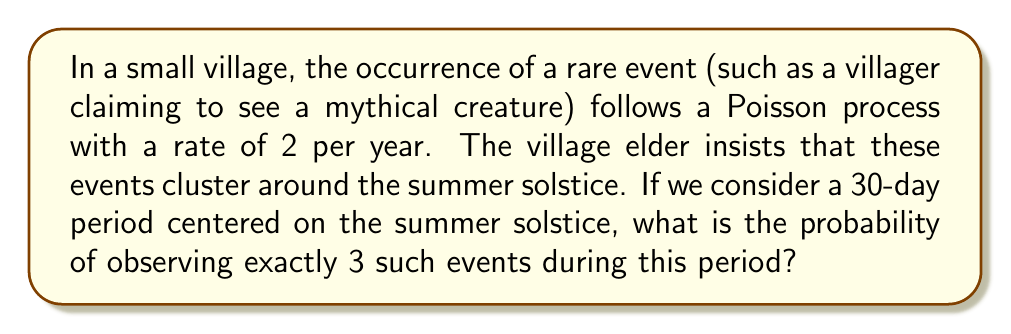Provide a solution to this math problem. To solve this problem, we'll use the Poisson distribution formula. Let's break it down step-by-step:

1. Identify the given information:
   - The rate of events is 2 per year
   - We're considering a 30-day period
   - We want the probability of exactly 3 events

2. Calculate the rate for the 30-day period:
   $\lambda = 2 \text{ events/year} \times \frac{30 \text{ days}}{365 \text{ days/year}} \approx 0.1644$ events

3. Use the Poisson probability mass function:
   $$P(X = k) = \frac{e^{-\lambda} \lambda^k}{k!}$$
   Where:
   - $\lambda$ is the average rate of events
   - $k$ is the number of events we're interested in (3 in this case)
   - $e$ is Euler's number (approximately 2.71828)

4. Plug in the values:
   $$P(X = 3) = \frac{e^{-0.1644} (0.1644)^3}{3!}$$

5. Calculate:
   $$P(X = 3) = \frac{0.8483 \times 0.004444}{6} \approx 0.000625$$

6. Convert to a percentage:
   $0.000625 \times 100\% = 0.0625\%$

This low probability suggests that observing exactly 3 events in this 30-day period is quite rare, supporting a skeptical view of the village elder's claim about event clustering.
Answer: 0.0625% 